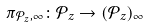<formula> <loc_0><loc_0><loc_500><loc_500>\pi _ { \mathcal { P } _ { z } , \infty } \colon \mathcal { P } _ { z } \to ( \mathcal { P } _ { z } ) _ { \infty }</formula> 